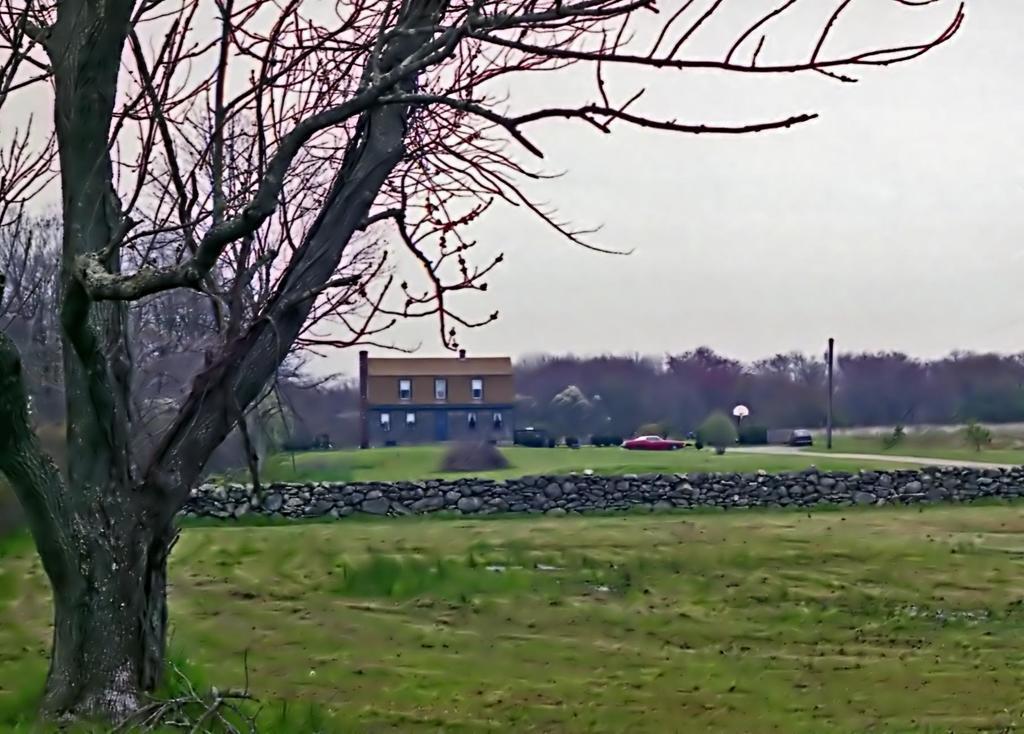Describe this image in one or two sentences. In this image we can see a tree. In the center of the image we can see a building with group of windows and door. A car is parked on the ground. In the background, we can see the sky. 